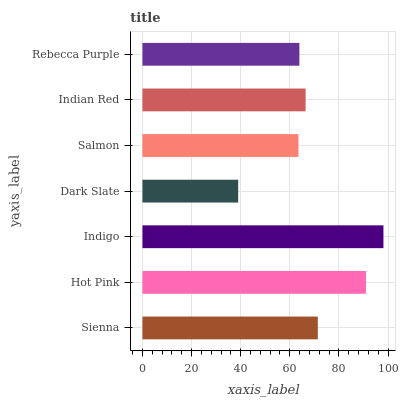Is Dark Slate the minimum?
Answer yes or no. Yes. Is Indigo the maximum?
Answer yes or no. Yes. Is Hot Pink the minimum?
Answer yes or no. No. Is Hot Pink the maximum?
Answer yes or no. No. Is Hot Pink greater than Sienna?
Answer yes or no. Yes. Is Sienna less than Hot Pink?
Answer yes or no. Yes. Is Sienna greater than Hot Pink?
Answer yes or no. No. Is Hot Pink less than Sienna?
Answer yes or no. No. Is Indian Red the high median?
Answer yes or no. Yes. Is Indian Red the low median?
Answer yes or no. Yes. Is Dark Slate the high median?
Answer yes or no. No. Is Hot Pink the low median?
Answer yes or no. No. 